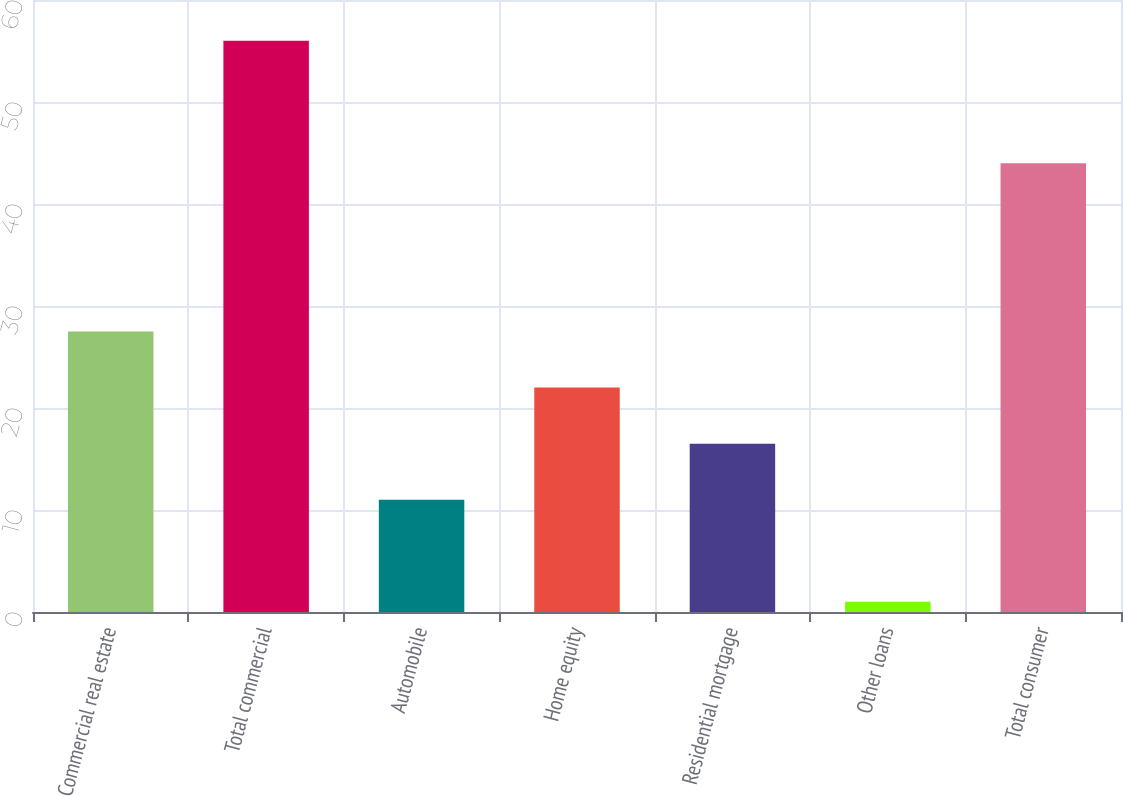Convert chart to OTSL. <chart><loc_0><loc_0><loc_500><loc_500><bar_chart><fcel>Commercial real estate<fcel>Total commercial<fcel>Automobile<fcel>Home equity<fcel>Residential mortgage<fcel>Other loans<fcel>Total consumer<nl><fcel>27.5<fcel>56<fcel>11<fcel>22<fcel>16.5<fcel>1<fcel>44<nl></chart> 